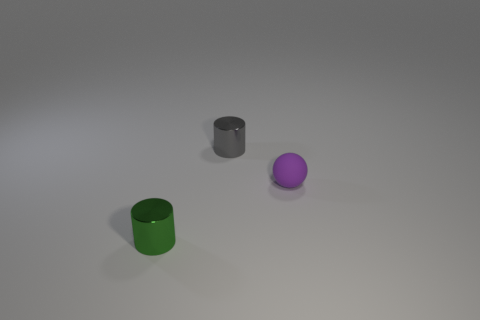The cylinder that is in front of the metal thing that is behind the purple object is what color?
Offer a very short reply. Green. Is the number of small objects in front of the matte thing less than the number of objects that are in front of the gray shiny object?
Your response must be concise. Yes. How many things are either things left of the gray metallic thing or big cyan things?
Your answer should be compact. 1. There is a cylinder in front of the ball; does it have the same size as the gray metal cylinder?
Offer a terse response. Yes. Are there fewer tiny metallic cylinders that are in front of the tiny gray metal cylinder than small rubber objects?
Make the answer very short. No. What material is the other cylinder that is the same size as the gray cylinder?
Your response must be concise. Metal. What number of small things are either green cylinders or gray matte blocks?
Ensure brevity in your answer.  1. What number of objects are either tiny metal cylinders that are in front of the small rubber object or small green cylinders that are left of the tiny purple ball?
Make the answer very short. 1. Are there fewer green things than objects?
Your response must be concise. Yes. What is the shape of the purple object that is the same size as the green cylinder?
Your response must be concise. Sphere. 